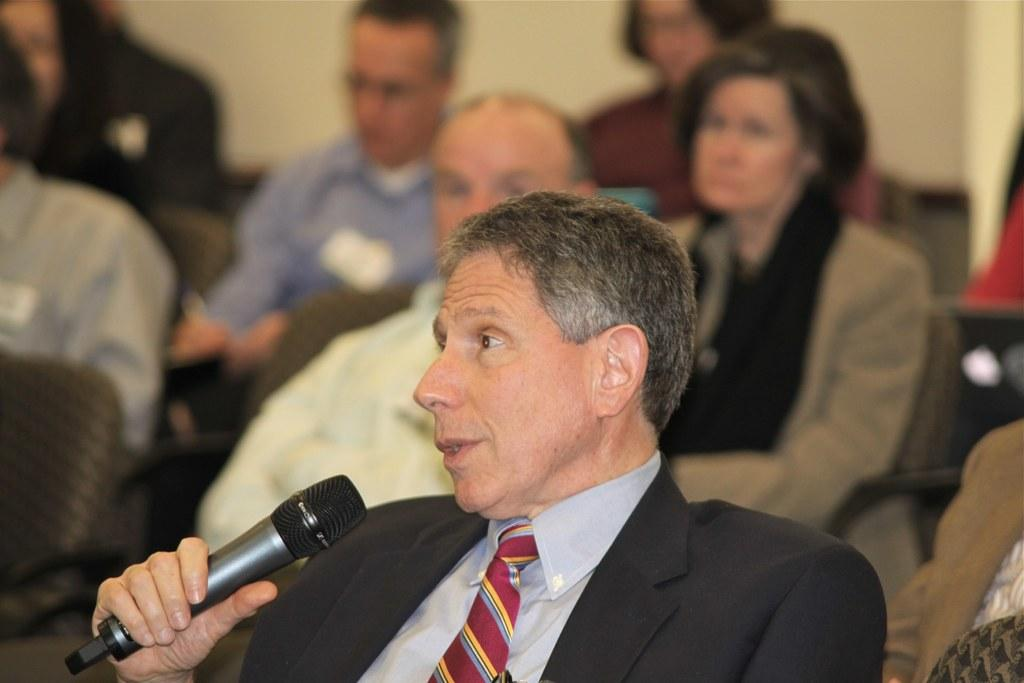What is the main subject of the image? The main subject of the image is a group of people. What are the people in the image doing? The people are seated on chairs. Can you describe the man in the image? The man in the image is holding a microphone. What is the man doing with the microphone? The man is speaking. What type of alley can be seen in the background of the image? There is no alley present in the image. How does the distribution of chairs affect the group's interaction in the image? The image does not provide information about the distribution of chairs or how it affects the group's interaction. 